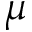Convert formula to latex. <formula><loc_0><loc_0><loc_500><loc_500>\mu</formula> 